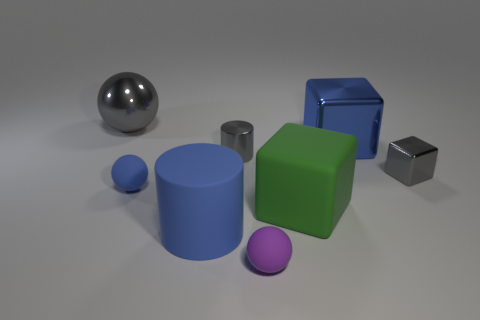Is there anything else that has the same shape as the tiny blue matte thing?
Ensure brevity in your answer.  Yes. What is the color of the other big object that is the same shape as the big green rubber object?
Offer a terse response. Blue. What is the big blue thing to the right of the tiny shiny cylinder made of?
Make the answer very short. Metal. The large metal sphere has what color?
Offer a very short reply. Gray. Is the size of the matte sphere behind the purple matte ball the same as the gray metallic sphere?
Give a very brief answer. No. What material is the large thing that is in front of the big rubber object right of the small rubber sphere in front of the large blue cylinder made of?
Provide a succinct answer. Rubber. There is a tiny rubber thing that is in front of the big blue matte cylinder; does it have the same color as the big metal thing behind the blue metallic thing?
Give a very brief answer. No. What material is the big gray thing left of the tiny thing that is right of the green matte block?
Provide a short and direct response. Metal. There is a shiny block that is the same size as the gray shiny cylinder; what color is it?
Ensure brevity in your answer.  Gray. There is a green thing; is its shape the same as the small gray object that is left of the large blue shiny object?
Your response must be concise. No. 